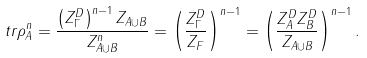<formula> <loc_0><loc_0><loc_500><loc_500>t r \rho ^ { n } _ { A } = \frac { \left ( Z ^ { D } _ { \Gamma } \right ) ^ { n - 1 } Z _ { A \cup B } } { Z ^ { n } _ { A \cup B } } = \left ( \frac { Z ^ { D } _ { \Gamma } } { Z _ { F } } \right ) ^ { n - 1 } = \left ( \frac { Z _ { A } ^ { D } Z _ { B } ^ { D } } { Z _ { A \cup B } } \right ) ^ { n - 1 } .</formula> 